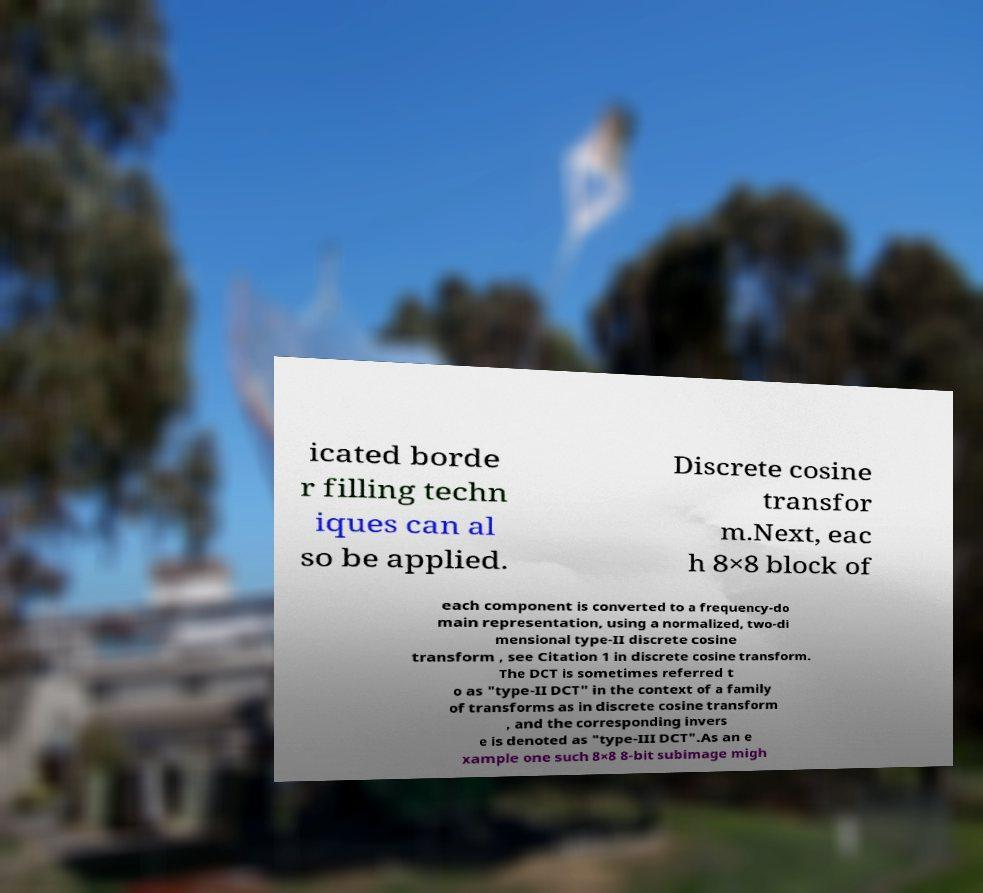Could you assist in decoding the text presented in this image and type it out clearly? icated borde r filling techn iques can al so be applied. Discrete cosine transfor m.Next, eac h 8×8 block of each component is converted to a frequency-do main representation, using a normalized, two-di mensional type-II discrete cosine transform , see Citation 1 in discrete cosine transform. The DCT is sometimes referred t o as "type-II DCT" in the context of a family of transforms as in discrete cosine transform , and the corresponding invers e is denoted as "type-III DCT".As an e xample one such 8×8 8-bit subimage migh 